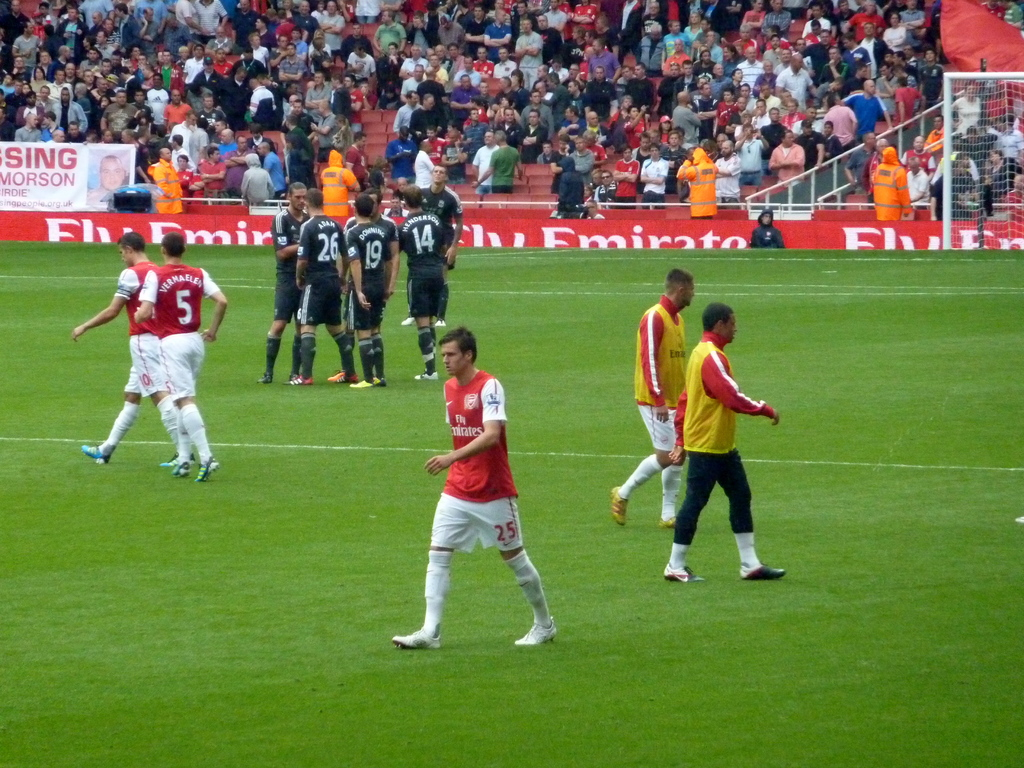Describe the atmosphere of the match as seen in the image. The stadium is filled with spectators indicating a lively match atmosphere, with focused players on the field adding to the intense and competitive vibe of the game. Can you tell what part of the game it is from the image? It's hard to determine the exact phase of the game, but the players' positions and movements suggest it might be either midway through an ongoing play or regrouping after a stop in play. 